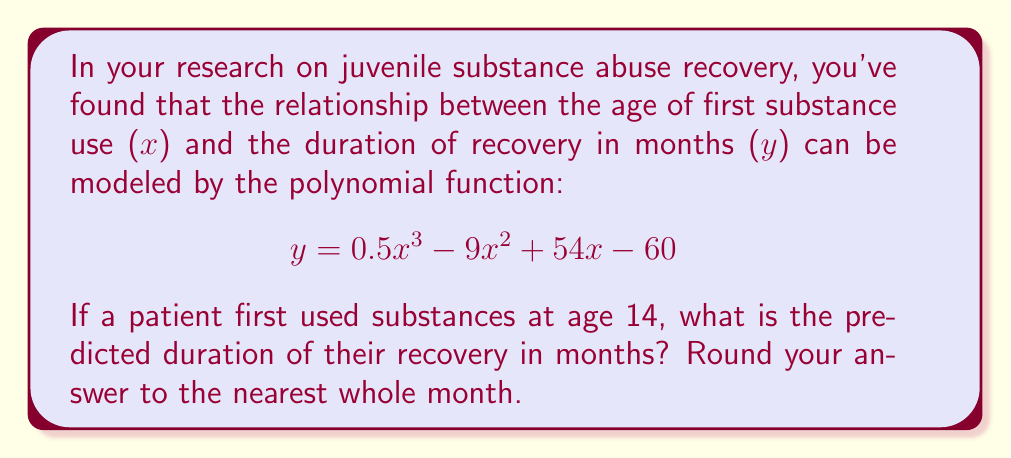Provide a solution to this math problem. To solve this problem, we need to substitute x = 14 into the given polynomial function and calculate the result. Let's break it down step by step:

1) The given function is:
   $$y = 0.5x^3 - 9x^2 + 54x - 60$$

2) Substitute x = 14:
   $$y = 0.5(14^3) - 9(14^2) + 54(14) - 60$$

3) Calculate each term:
   - $0.5(14^3) = 0.5(2744) = 1372$
   - $9(14^2) = 9(196) = 1764$
   - $54(14) = 756$
   - The constant term is -60

4) Now, let's add these terms:
   $$y = 1372 - 1764 + 756 - 60$$

5) Simplify:
   $$y = 304$$

6) Round to the nearest whole month:
   $$y ≈ 304$$ (no rounding needed in this case)

Therefore, the predicted duration of recovery for a patient who first used substances at age 14 is 304 months.
Answer: 304 months 